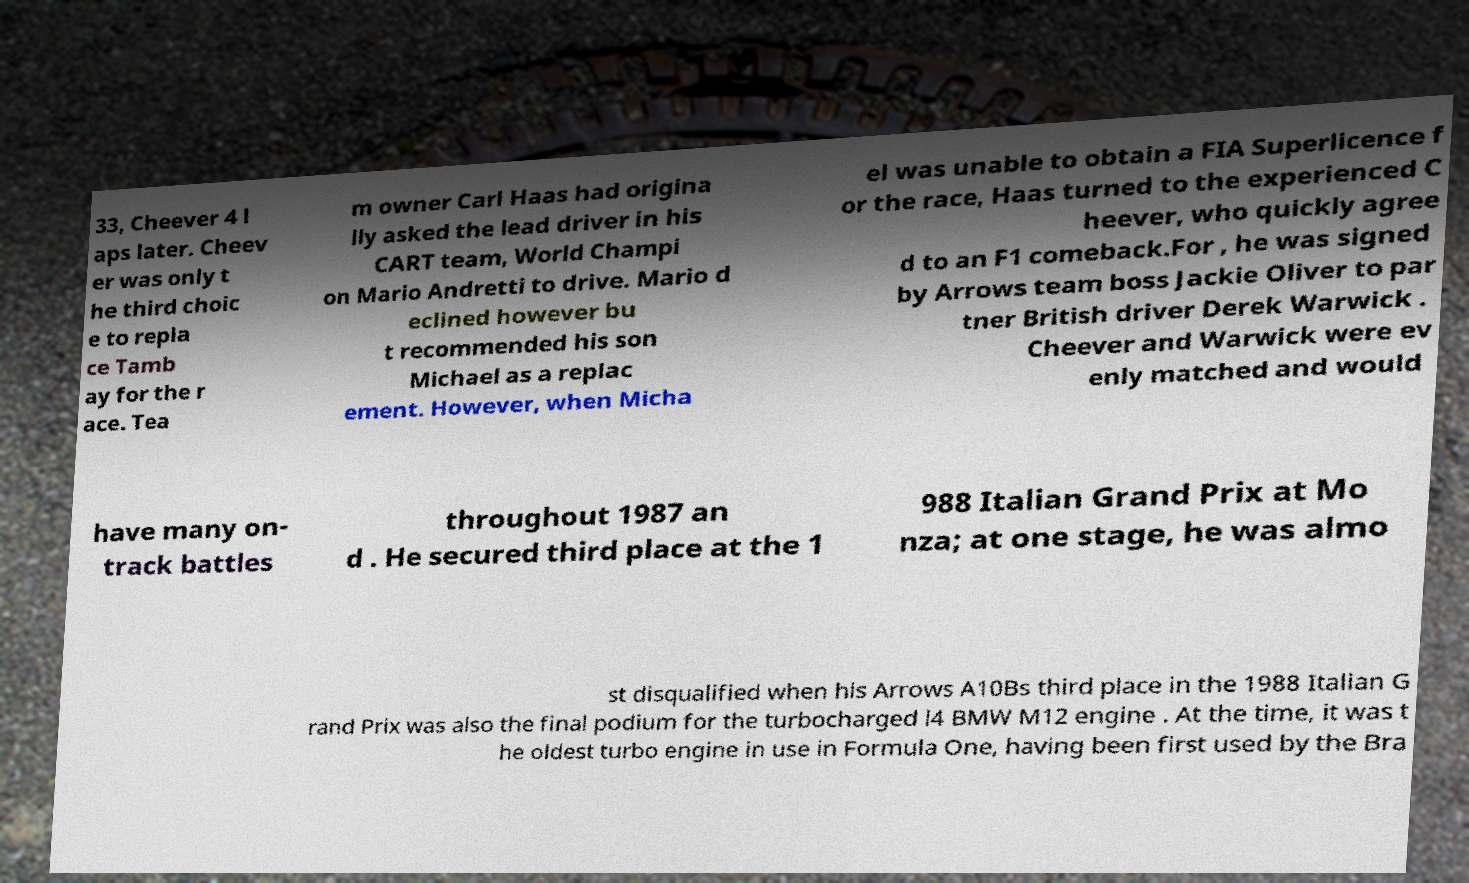For documentation purposes, I need the text within this image transcribed. Could you provide that? 33, Cheever 4 l aps later. Cheev er was only t he third choic e to repla ce Tamb ay for the r ace. Tea m owner Carl Haas had origina lly asked the lead driver in his CART team, World Champi on Mario Andretti to drive. Mario d eclined however bu t recommended his son Michael as a replac ement. However, when Micha el was unable to obtain a FIA Superlicence f or the race, Haas turned to the experienced C heever, who quickly agree d to an F1 comeback.For , he was signed by Arrows team boss Jackie Oliver to par tner British driver Derek Warwick . Cheever and Warwick were ev enly matched and would have many on- track battles throughout 1987 an d . He secured third place at the 1 988 Italian Grand Prix at Mo nza; at one stage, he was almo st disqualified when his Arrows A10Bs third place in the 1988 Italian G rand Prix was also the final podium for the turbocharged l4 BMW M12 engine . At the time, it was t he oldest turbo engine in use in Formula One, having been first used by the Bra 